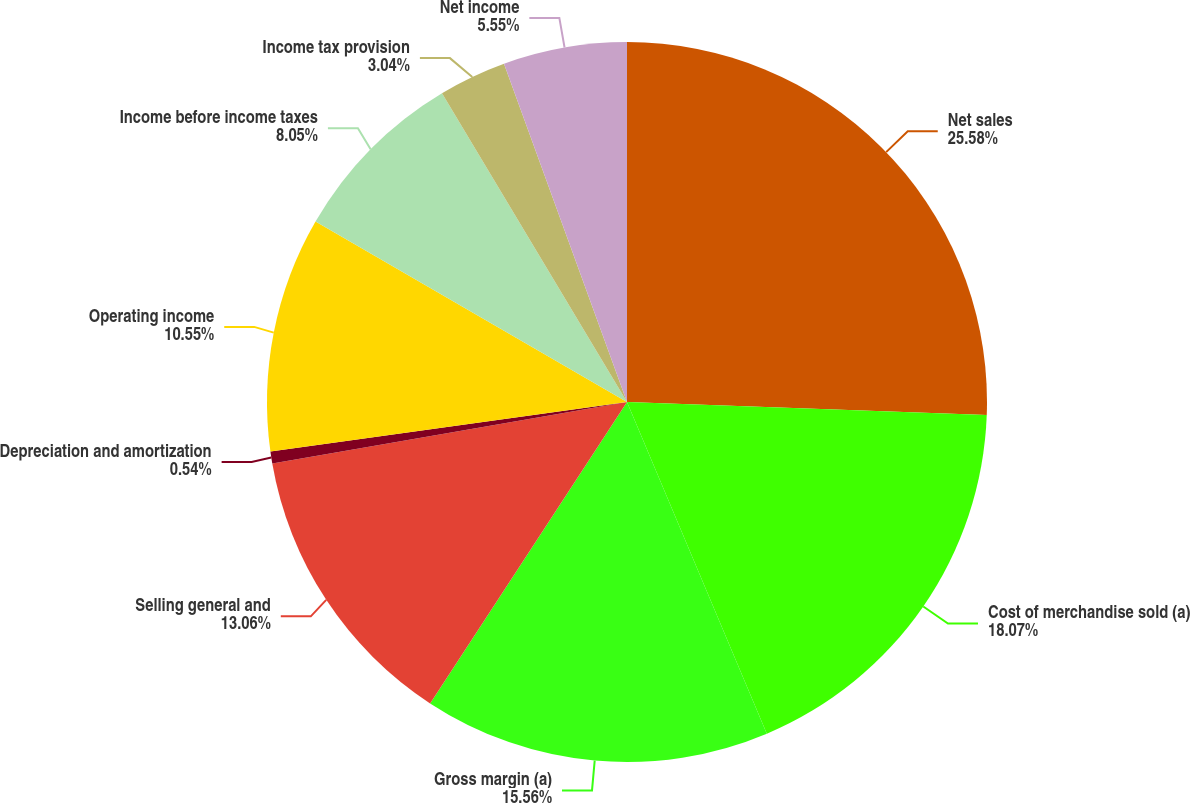<chart> <loc_0><loc_0><loc_500><loc_500><pie_chart><fcel>Net sales<fcel>Cost of merchandise sold (a)<fcel>Gross margin (a)<fcel>Selling general and<fcel>Depreciation and amortization<fcel>Operating income<fcel>Income before income taxes<fcel>Income tax provision<fcel>Net income<nl><fcel>25.58%<fcel>18.07%<fcel>15.56%<fcel>13.06%<fcel>0.54%<fcel>10.55%<fcel>8.05%<fcel>3.04%<fcel>5.55%<nl></chart> 